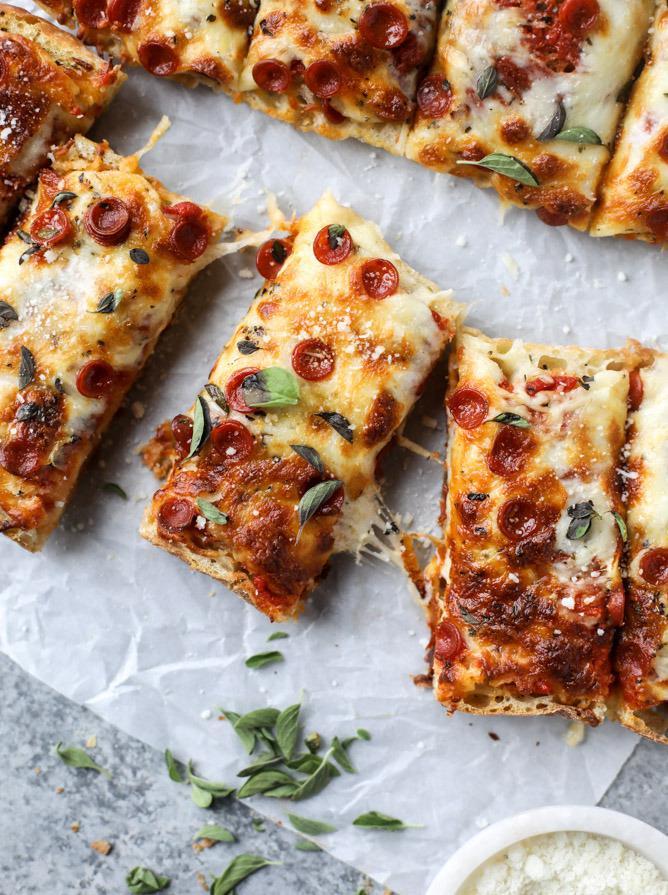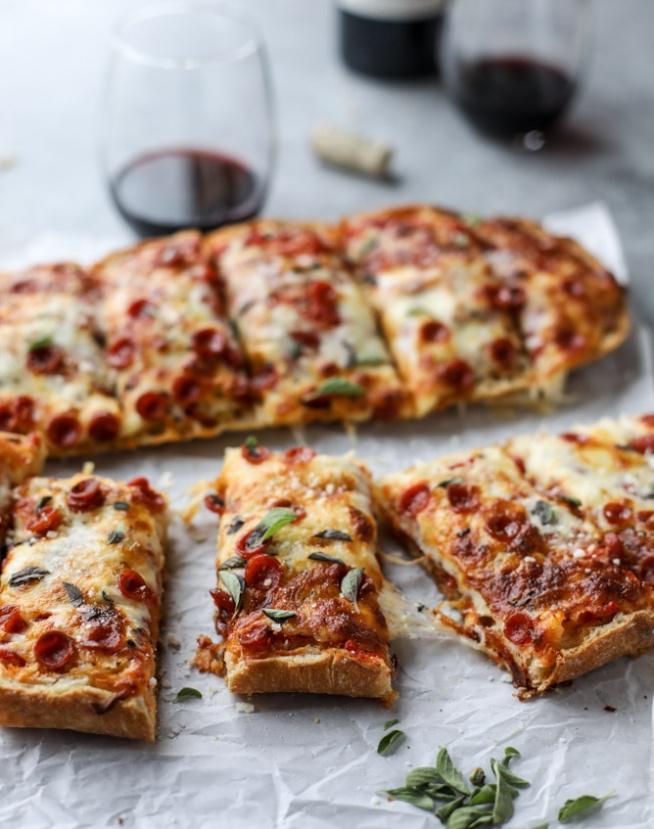The first image is the image on the left, the second image is the image on the right. Assess this claim about the two images: "The left image shows a round pizza topped with meatballs, and the right image shows individual 'pizzas' with topping on bread.". Correct or not? Answer yes or no. No. The first image is the image on the left, the second image is the image on the right. Given the left and right images, does the statement "The pizza in both images is french bread pizza." hold true? Answer yes or no. Yes. 